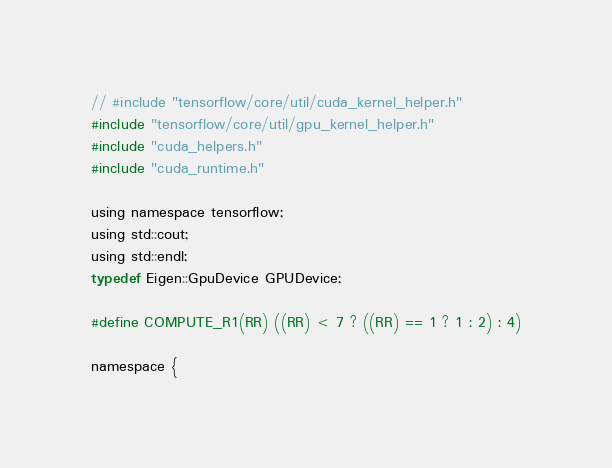<code> <loc_0><loc_0><loc_500><loc_500><_Cuda_>// #include "tensorflow/core/util/cuda_kernel_helper.h"
#include "tensorflow/core/util/gpu_kernel_helper.h"
#include "cuda_helpers.h"
#include "cuda_runtime.h"

using namespace tensorflow;
using std::cout;
using std::endl;
typedef Eigen::GpuDevice GPUDevice;

#define COMPUTE_R1(RR) ((RR) < 7 ? ((RR) == 1 ? 1 : 2) : 4)

namespace {</code> 